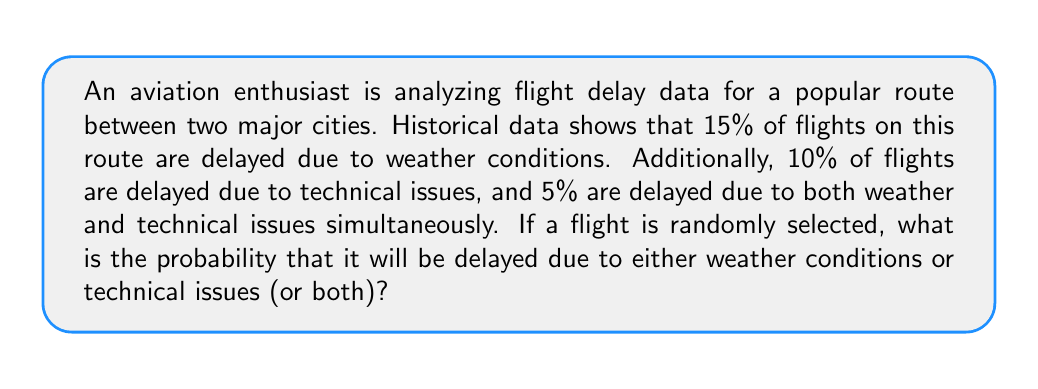Can you solve this math problem? Let's approach this step-by-step using set theory and probability concepts:

1. Define our events:
   $W$: Flight is delayed due to weather conditions
   $T$: Flight is delayed due to technical issues

2. Given probabilities:
   $P(W) = 0.15$ (15%)
   $P(T) = 0.10$ (10%)
   $P(W \cap T) = 0.05$ (5%)

3. We need to find $P(W \cup T)$, which is the probability of a flight being delayed due to weather OR technical issues (or both).

4. We can use the addition rule of probability:
   $$P(W \cup T) = P(W) + P(T) - P(W \cap T)$$

5. This formula accounts for the overlap (flights delayed by both reasons) to avoid double-counting.

6. Substituting the given values:
   $$P(W \cup T) = 0.15 + 0.10 - 0.05$$

7. Calculating:
   $$P(W \cup T) = 0.20 = 20\%$$

Therefore, the probability that a randomly selected flight will be delayed due to either weather conditions or technical issues (or both) is 20%.
Answer: 20% or 0.20 